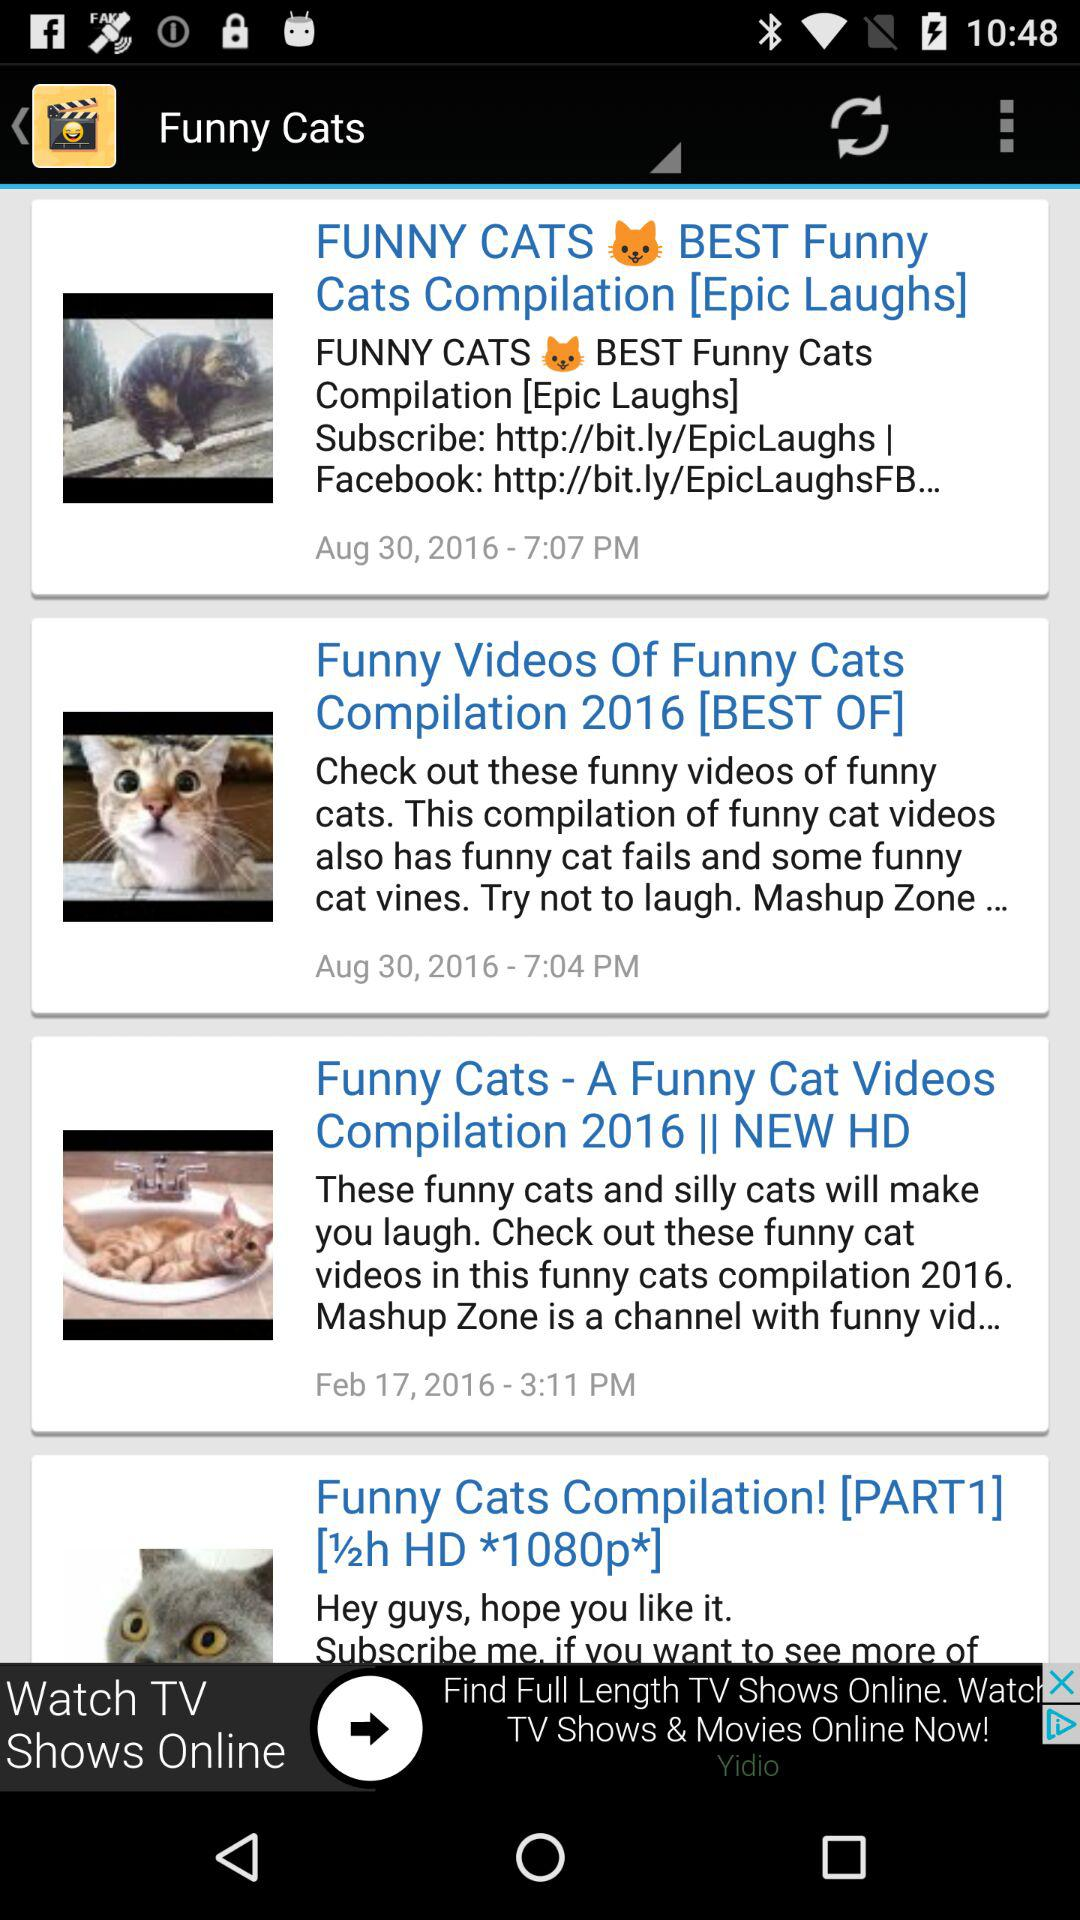What is the posted date of the "Funny Videos of Funny Cats Compilation 2016"? The posted date is August 30, 2016. 